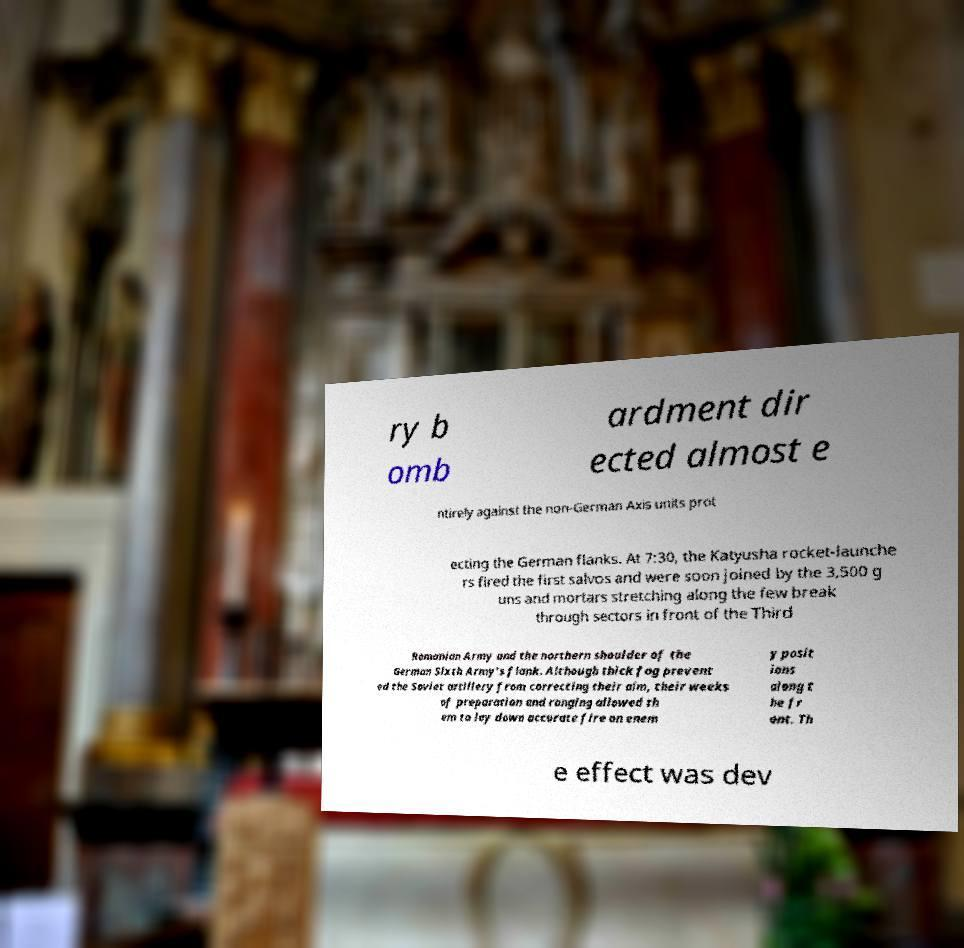There's text embedded in this image that I need extracted. Can you transcribe it verbatim? ry b omb ardment dir ected almost e ntirely against the non-German Axis units prot ecting the German flanks. At 7:30, the Katyusha rocket-launche rs fired the first salvos and were soon joined by the 3,500 g uns and mortars stretching along the few break through sectors in front of the Third Romanian Army and the northern shoulder of the German Sixth Army's flank. Although thick fog prevent ed the Soviet artillery from correcting their aim, their weeks of preparation and ranging allowed th em to lay down accurate fire on enem y posit ions along t he fr ont. Th e effect was dev 